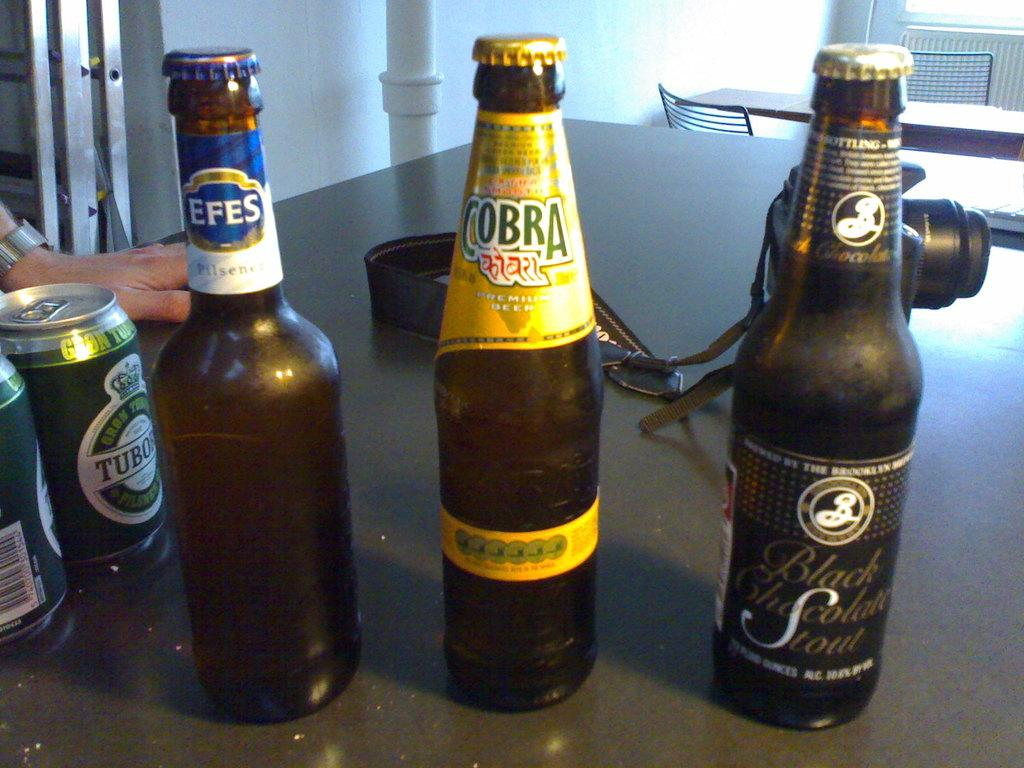<image>
Share a concise interpretation of the image provided. Three brown bottles of beer sit on a table with Cobra in the middle. 